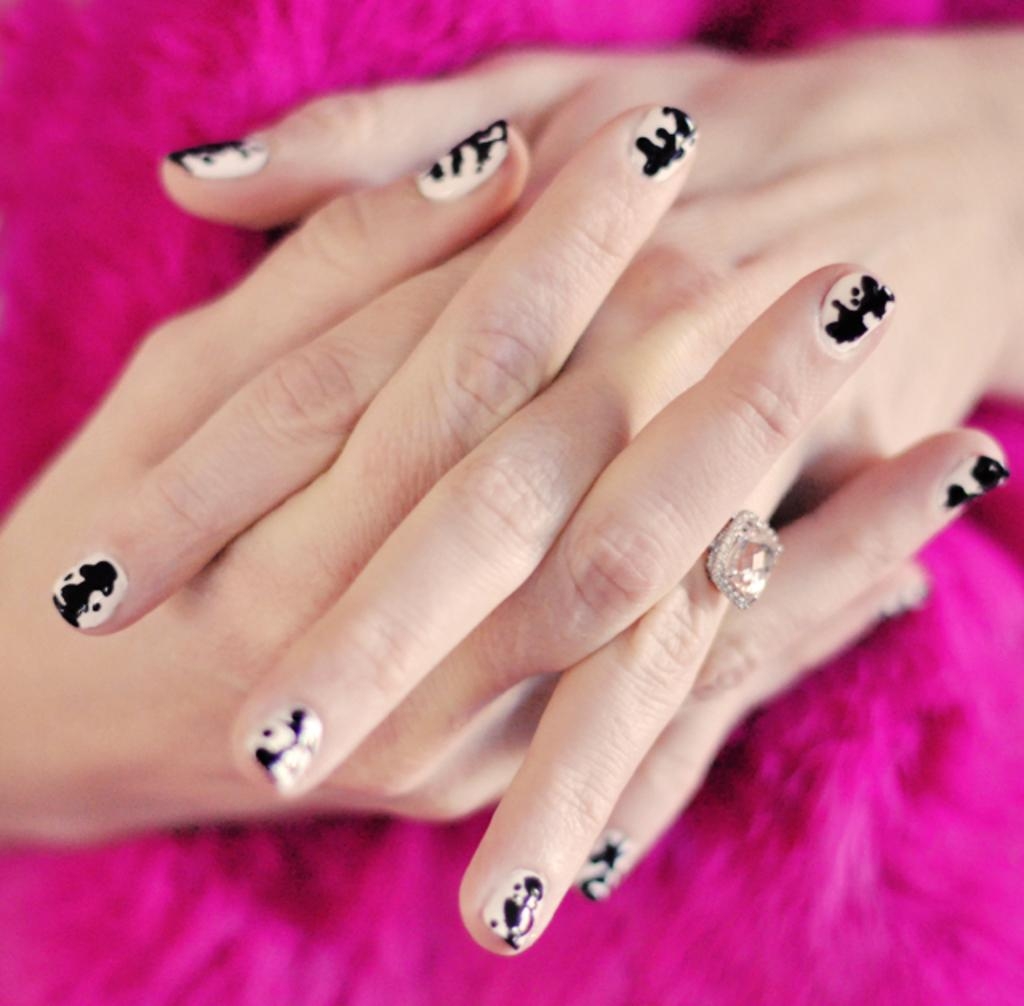Who is the main subject in the image? There is a woman in the image. What is the woman doing in the image? The woman is having her nails painted. What color is the nail polish being used? The nail polish is black and white in color. What is the color of the background in the image? The background of the image is pink. What type of fruit is being used to paint the woman's nails in the image? There is no fruit present in the image, and the woman's nails are being painted with black and white nail polish. 